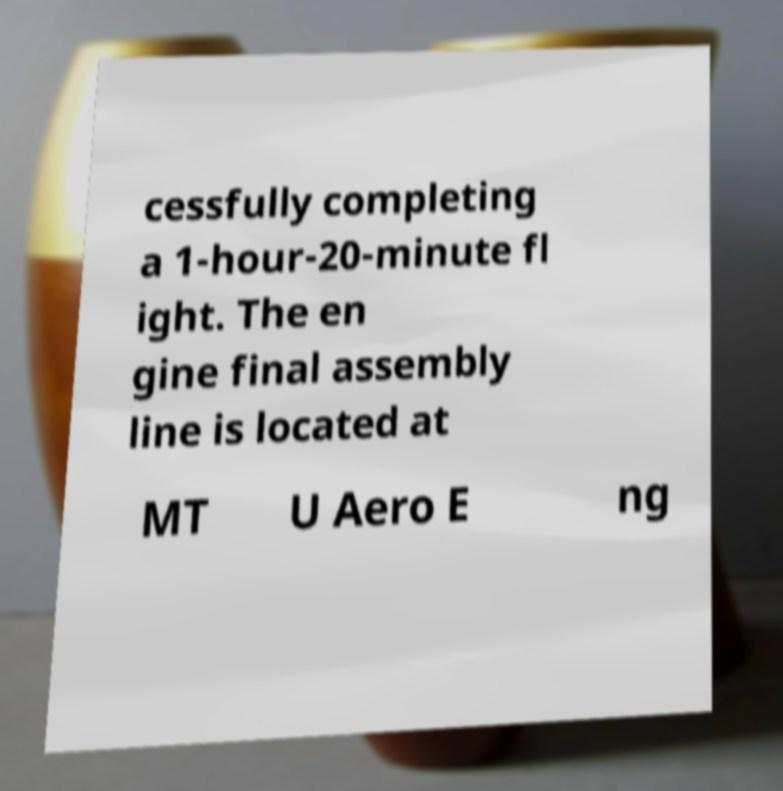Can you read and provide the text displayed in the image?This photo seems to have some interesting text. Can you extract and type it out for me? cessfully completing a 1-hour-20-minute fl ight. The en gine final assembly line is located at MT U Aero E ng 